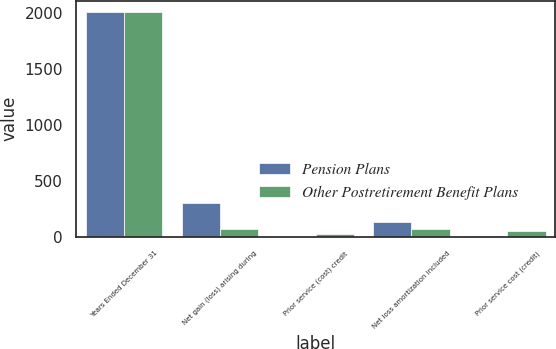Convert chart. <chart><loc_0><loc_0><loc_500><loc_500><stacked_bar_chart><ecel><fcel>Years Ended December 31<fcel>Net gain (loss) arising during<fcel>Prior service (cost) credit<fcel>Net loss amortization included<fcel>Prior service cost (credit)<nl><fcel>Pension Plans<fcel>2009<fcel>302.5<fcel>0.5<fcel>127.5<fcel>8.7<nl><fcel>Other Postretirement Benefit Plans<fcel>2009<fcel>70.9<fcel>23.5<fcel>67.7<fcel>48.8<nl></chart> 